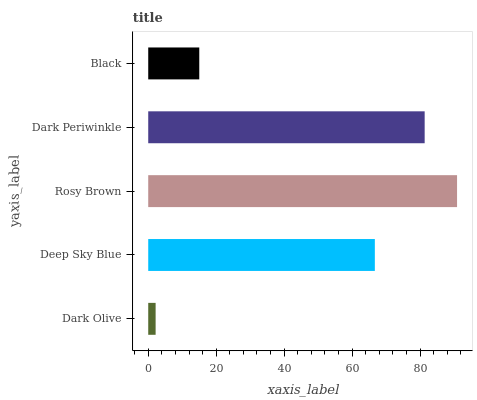Is Dark Olive the minimum?
Answer yes or no. Yes. Is Rosy Brown the maximum?
Answer yes or no. Yes. Is Deep Sky Blue the minimum?
Answer yes or no. No. Is Deep Sky Blue the maximum?
Answer yes or no. No. Is Deep Sky Blue greater than Dark Olive?
Answer yes or no. Yes. Is Dark Olive less than Deep Sky Blue?
Answer yes or no. Yes. Is Dark Olive greater than Deep Sky Blue?
Answer yes or no. No. Is Deep Sky Blue less than Dark Olive?
Answer yes or no. No. Is Deep Sky Blue the high median?
Answer yes or no. Yes. Is Deep Sky Blue the low median?
Answer yes or no. Yes. Is Dark Olive the high median?
Answer yes or no. No. Is Black the low median?
Answer yes or no. No. 